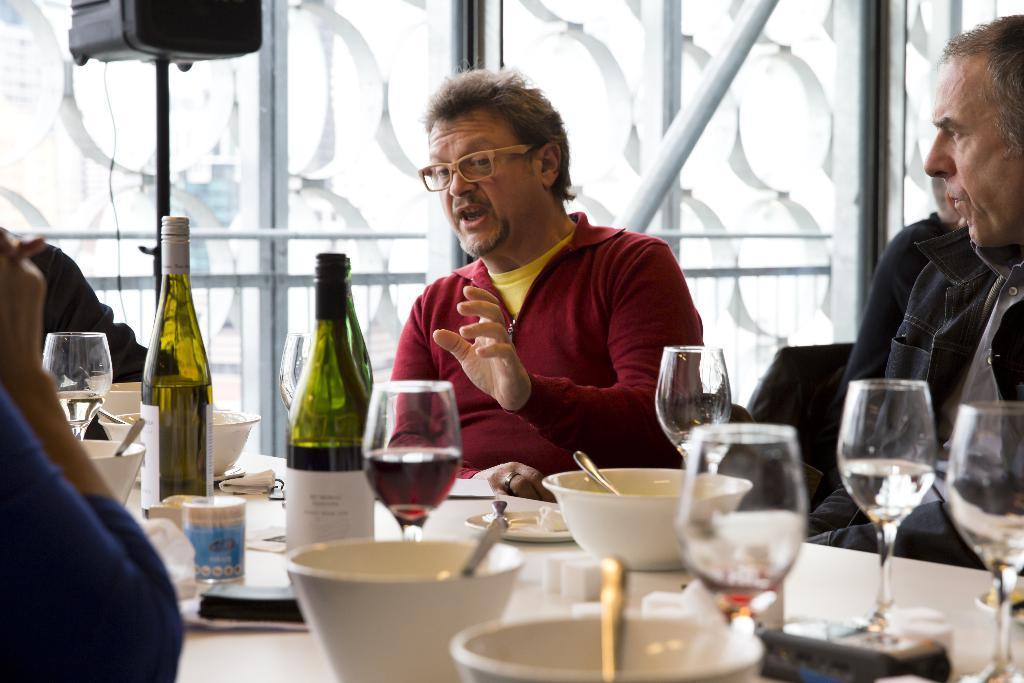Please provide a concise description of this image. There are some people sitting in chairs in front of a table which has wine bottles,glasses and some other objects on it. 